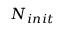<formula> <loc_0><loc_0><loc_500><loc_500>N _ { i n i t }</formula> 